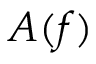Convert formula to latex. <formula><loc_0><loc_0><loc_500><loc_500>A ( f )</formula> 